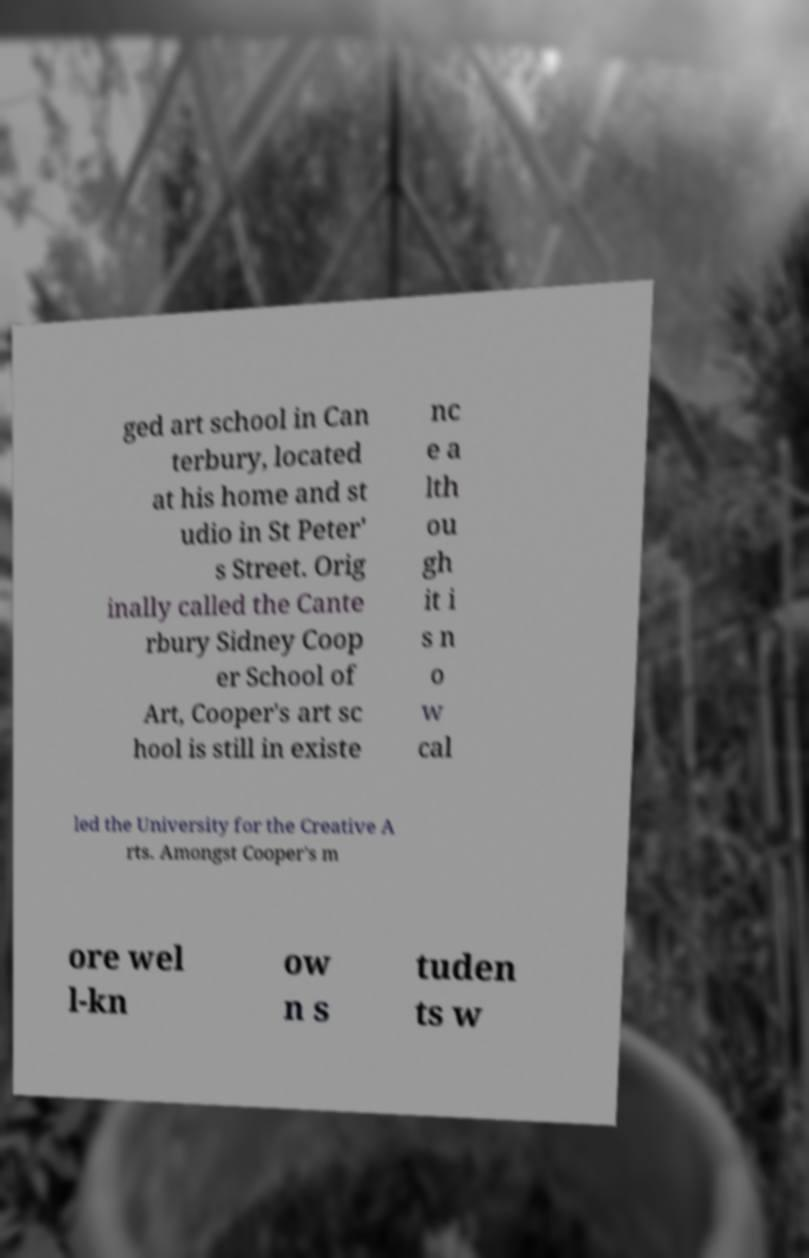What messages or text are displayed in this image? I need them in a readable, typed format. ged art school in Can terbury, located at his home and st udio in St Peter' s Street. Orig inally called the Cante rbury Sidney Coop er School of Art, Cooper's art sc hool is still in existe nc e a lth ou gh it i s n o w cal led the University for the Creative A rts. Amongst Cooper's m ore wel l-kn ow n s tuden ts w 